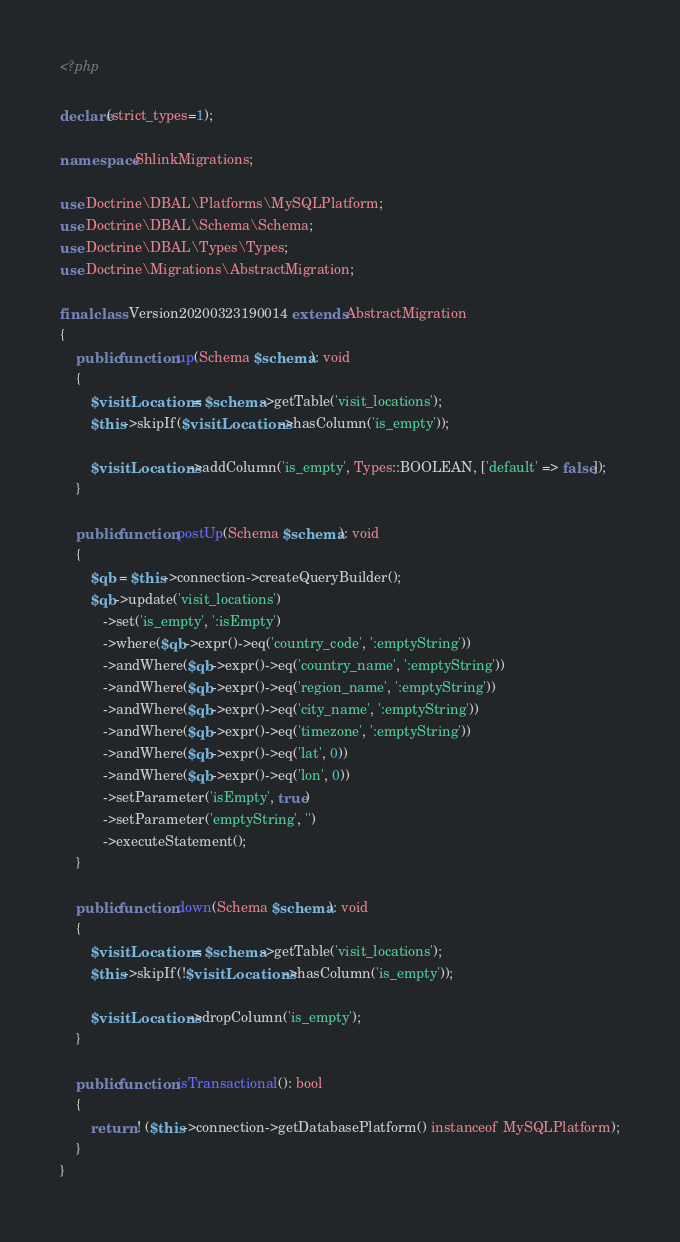Convert code to text. <code><loc_0><loc_0><loc_500><loc_500><_PHP_><?php

declare(strict_types=1);

namespace ShlinkMigrations;

use Doctrine\DBAL\Platforms\MySQLPlatform;
use Doctrine\DBAL\Schema\Schema;
use Doctrine\DBAL\Types\Types;
use Doctrine\Migrations\AbstractMigration;

final class Version20200323190014 extends AbstractMigration
{
    public function up(Schema $schema): void
    {
        $visitLocations = $schema->getTable('visit_locations');
        $this->skipIf($visitLocations->hasColumn('is_empty'));

        $visitLocations->addColumn('is_empty', Types::BOOLEAN, ['default' => false]);
    }

    public function postUp(Schema $schema): void
    {
        $qb = $this->connection->createQueryBuilder();
        $qb->update('visit_locations')
           ->set('is_empty', ':isEmpty')
           ->where($qb->expr()->eq('country_code', ':emptyString'))
           ->andWhere($qb->expr()->eq('country_name', ':emptyString'))
           ->andWhere($qb->expr()->eq('region_name', ':emptyString'))
           ->andWhere($qb->expr()->eq('city_name', ':emptyString'))
           ->andWhere($qb->expr()->eq('timezone', ':emptyString'))
           ->andWhere($qb->expr()->eq('lat', 0))
           ->andWhere($qb->expr()->eq('lon', 0))
           ->setParameter('isEmpty', true)
           ->setParameter('emptyString', '')
           ->executeStatement();
    }

    public function down(Schema $schema): void
    {
        $visitLocations = $schema->getTable('visit_locations');
        $this->skipIf(!$visitLocations->hasColumn('is_empty'));

        $visitLocations->dropColumn('is_empty');
    }

    public function isTransactional(): bool
    {
        return ! ($this->connection->getDatabasePlatform() instanceof MySQLPlatform);
    }
}
</code> 